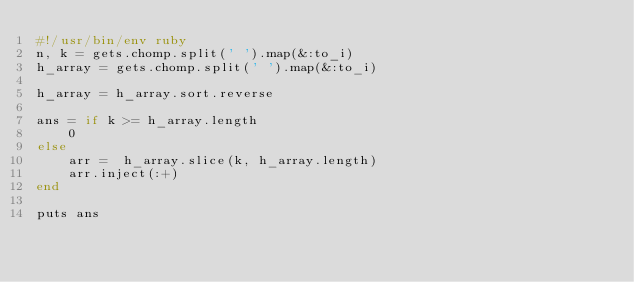Convert code to text. <code><loc_0><loc_0><loc_500><loc_500><_Ruby_>#!/usr/bin/env ruby
n, k = gets.chomp.split(' ').map(&:to_i)
h_array = gets.chomp.split(' ').map(&:to_i)
 
h_array = h_array.sort.reverse

ans = if k >= h_array.length
    0
else
    arr =  h_array.slice(k, h_array.length)
    arr.inject(:+)
end

puts ans

</code> 